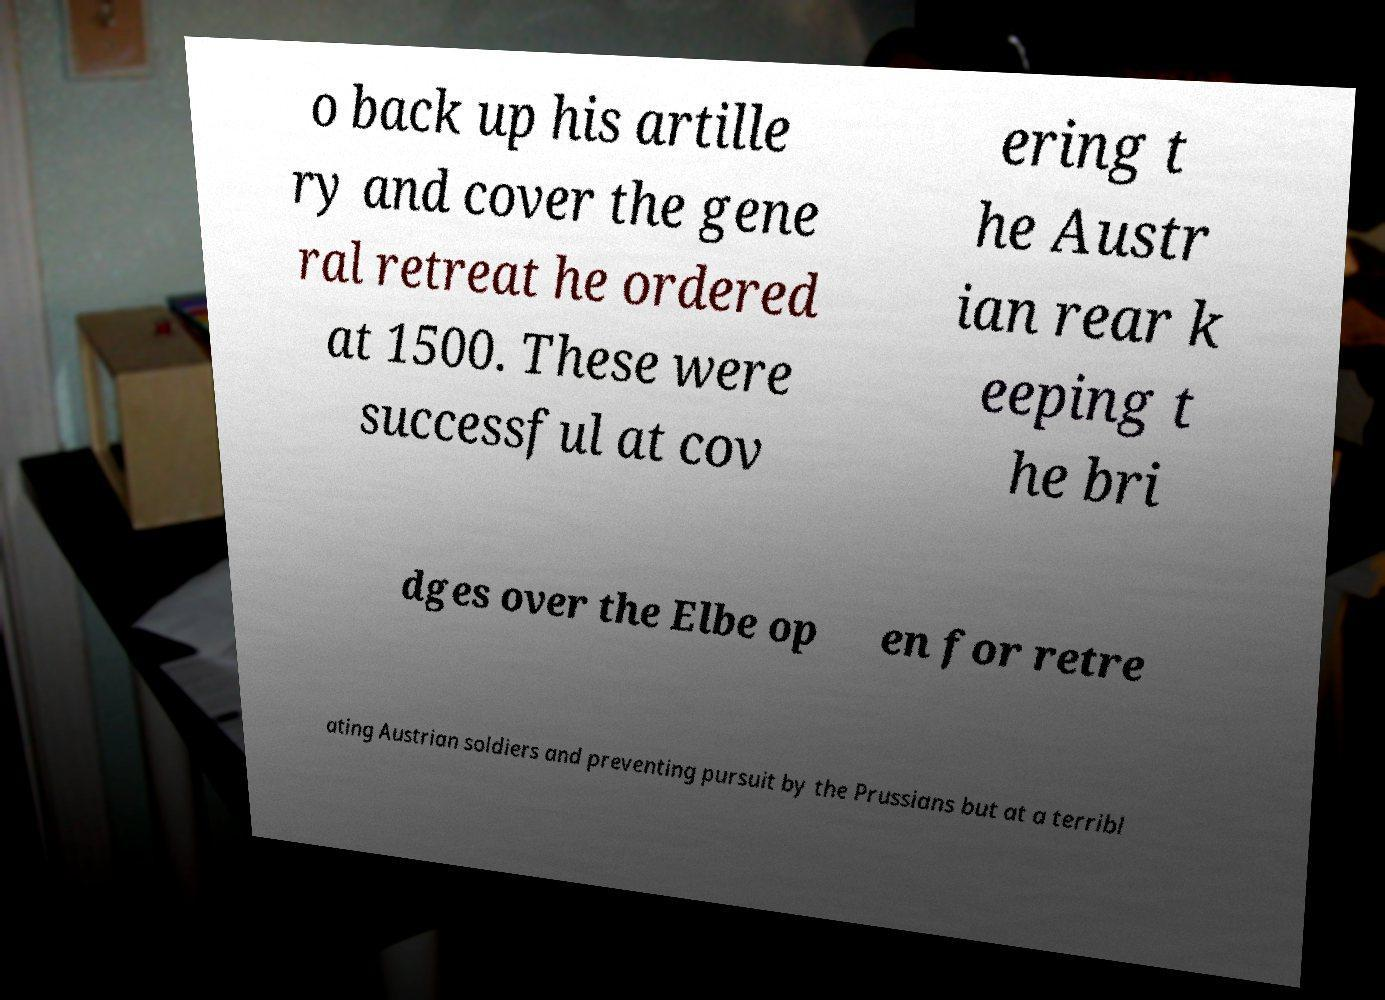What messages or text are displayed in this image? I need them in a readable, typed format. o back up his artille ry and cover the gene ral retreat he ordered at 1500. These were successful at cov ering t he Austr ian rear k eeping t he bri dges over the Elbe op en for retre ating Austrian soldiers and preventing pursuit by the Prussians but at a terribl 